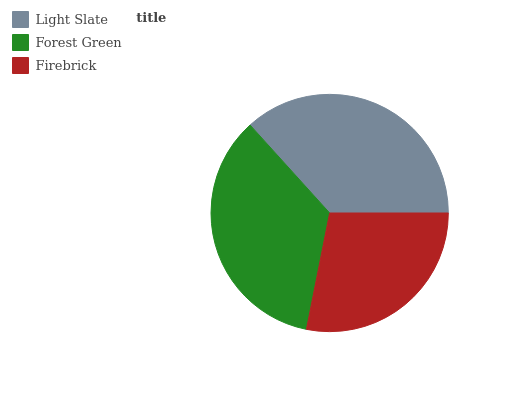Is Firebrick the minimum?
Answer yes or no. Yes. Is Light Slate the maximum?
Answer yes or no. Yes. Is Forest Green the minimum?
Answer yes or no. No. Is Forest Green the maximum?
Answer yes or no. No. Is Light Slate greater than Forest Green?
Answer yes or no. Yes. Is Forest Green less than Light Slate?
Answer yes or no. Yes. Is Forest Green greater than Light Slate?
Answer yes or no. No. Is Light Slate less than Forest Green?
Answer yes or no. No. Is Forest Green the high median?
Answer yes or no. Yes. Is Forest Green the low median?
Answer yes or no. Yes. Is Light Slate the high median?
Answer yes or no. No. Is Firebrick the low median?
Answer yes or no. No. 